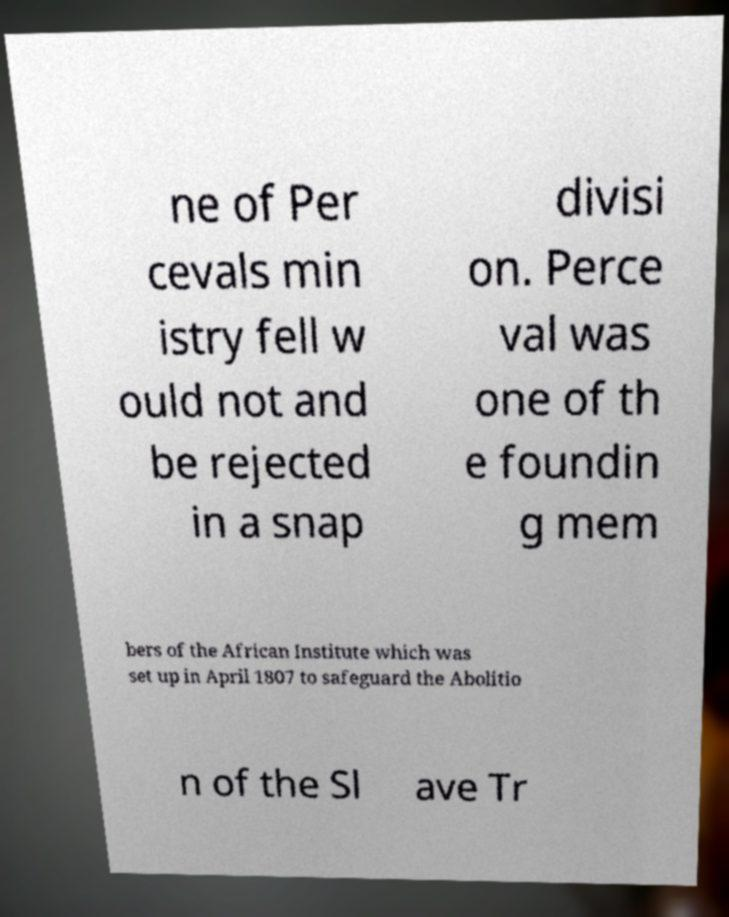For documentation purposes, I need the text within this image transcribed. Could you provide that? ne of Per cevals min istry fell w ould not and be rejected in a snap divisi on. Perce val was one of th e foundin g mem bers of the African Institute which was set up in April 1807 to safeguard the Abolitio n of the Sl ave Tr 